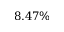Convert formula to latex. <formula><loc_0><loc_0><loc_500><loc_500>8 . 4 7 \%</formula> 